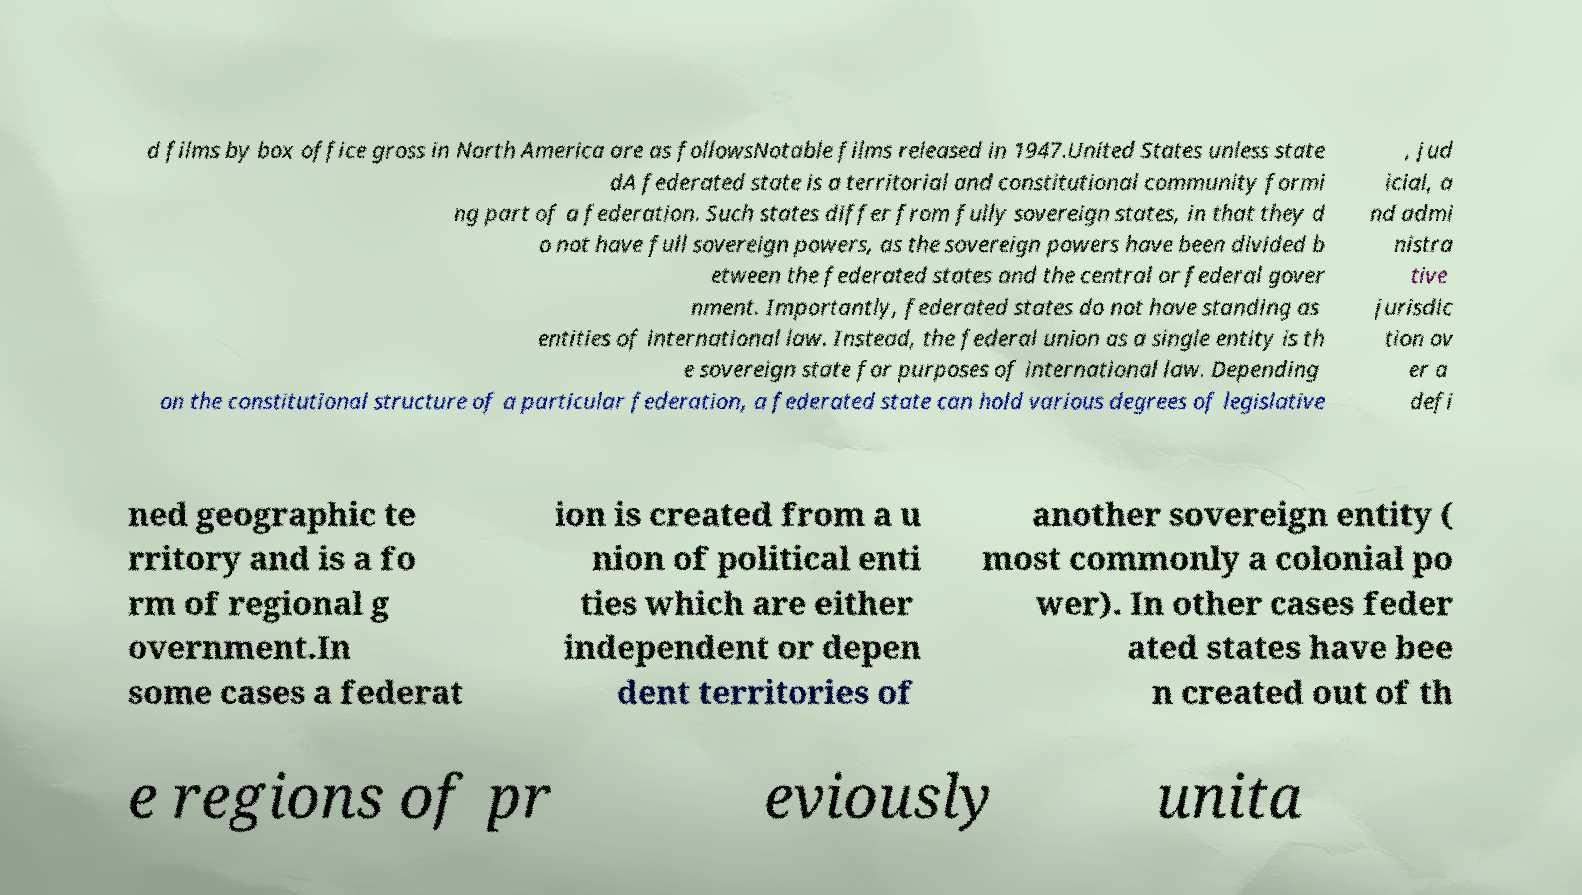Can you read and provide the text displayed in the image?This photo seems to have some interesting text. Can you extract and type it out for me? d films by box office gross in North America are as followsNotable films released in 1947.United States unless state dA federated state is a territorial and constitutional community formi ng part of a federation. Such states differ from fully sovereign states, in that they d o not have full sovereign powers, as the sovereign powers have been divided b etween the federated states and the central or federal gover nment. Importantly, federated states do not have standing as entities of international law. Instead, the federal union as a single entity is th e sovereign state for purposes of international law. Depending on the constitutional structure of a particular federation, a federated state can hold various degrees of legislative , jud icial, a nd admi nistra tive jurisdic tion ov er a defi ned geographic te rritory and is a fo rm of regional g overnment.In some cases a federat ion is created from a u nion of political enti ties which are either independent or depen dent territories of another sovereign entity ( most commonly a colonial po wer). In other cases feder ated states have bee n created out of th e regions of pr eviously unita 